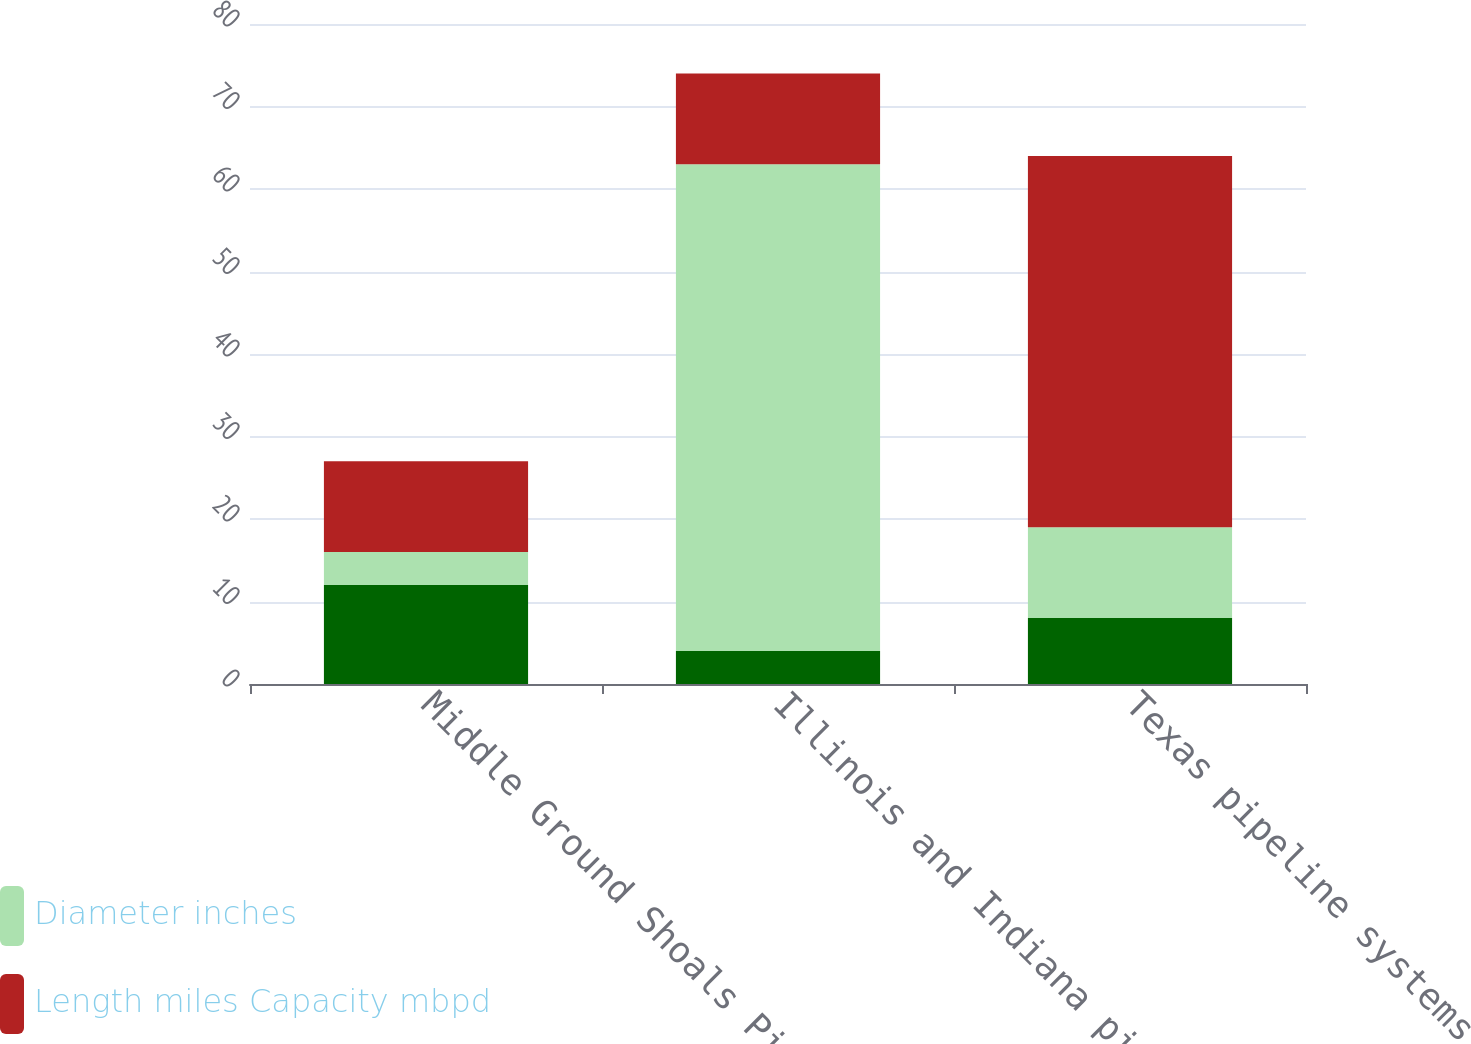<chart> <loc_0><loc_0><loc_500><loc_500><stacked_bar_chart><ecel><fcel>Middle Ground Shoals Pipeline<fcel>Illinois and Indiana pipeline<fcel>Texas pipeline systems<nl><fcel>nan<fcel>12<fcel>4<fcel>8<nl><fcel>Diameter inches<fcel>4<fcel>59<fcel>11<nl><fcel>Length miles Capacity mbpd<fcel>11<fcel>11<fcel>45<nl></chart> 